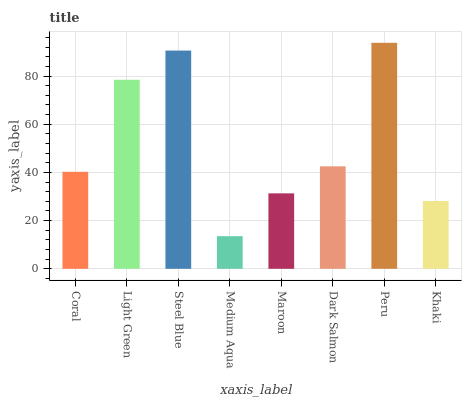Is Medium Aqua the minimum?
Answer yes or no. Yes. Is Peru the maximum?
Answer yes or no. Yes. Is Light Green the minimum?
Answer yes or no. No. Is Light Green the maximum?
Answer yes or no. No. Is Light Green greater than Coral?
Answer yes or no. Yes. Is Coral less than Light Green?
Answer yes or no. Yes. Is Coral greater than Light Green?
Answer yes or no. No. Is Light Green less than Coral?
Answer yes or no. No. Is Dark Salmon the high median?
Answer yes or no. Yes. Is Coral the low median?
Answer yes or no. Yes. Is Peru the high median?
Answer yes or no. No. Is Steel Blue the low median?
Answer yes or no. No. 